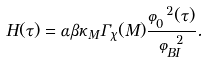Convert formula to latex. <formula><loc_0><loc_0><loc_500><loc_500>H ( \tau ) = \alpha \beta \kappa _ { M } \Gamma _ { \chi } ( M ) \frac { \varphi _ { 0 } ^ { 2 } ( \tau ) } { \varphi _ { B I } ^ { 2 } } .</formula> 